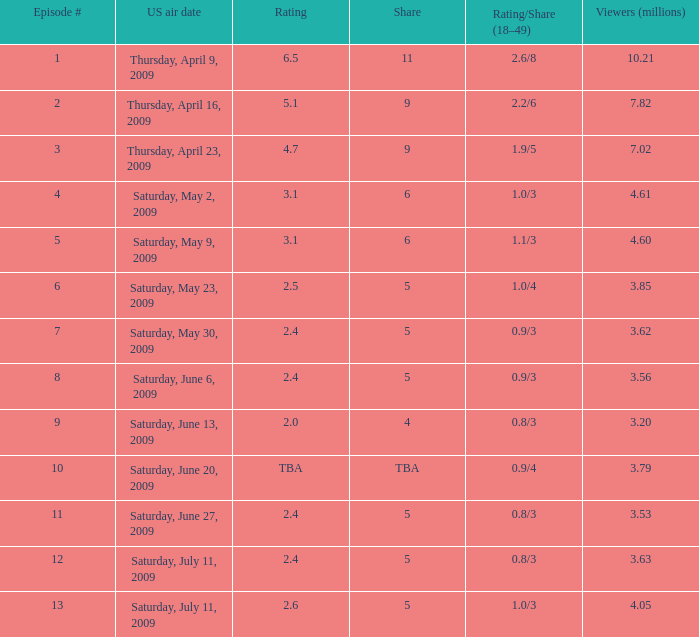What is the average number of million viewers that watched an episode before episode 11 with a share of 4? 3.2. 